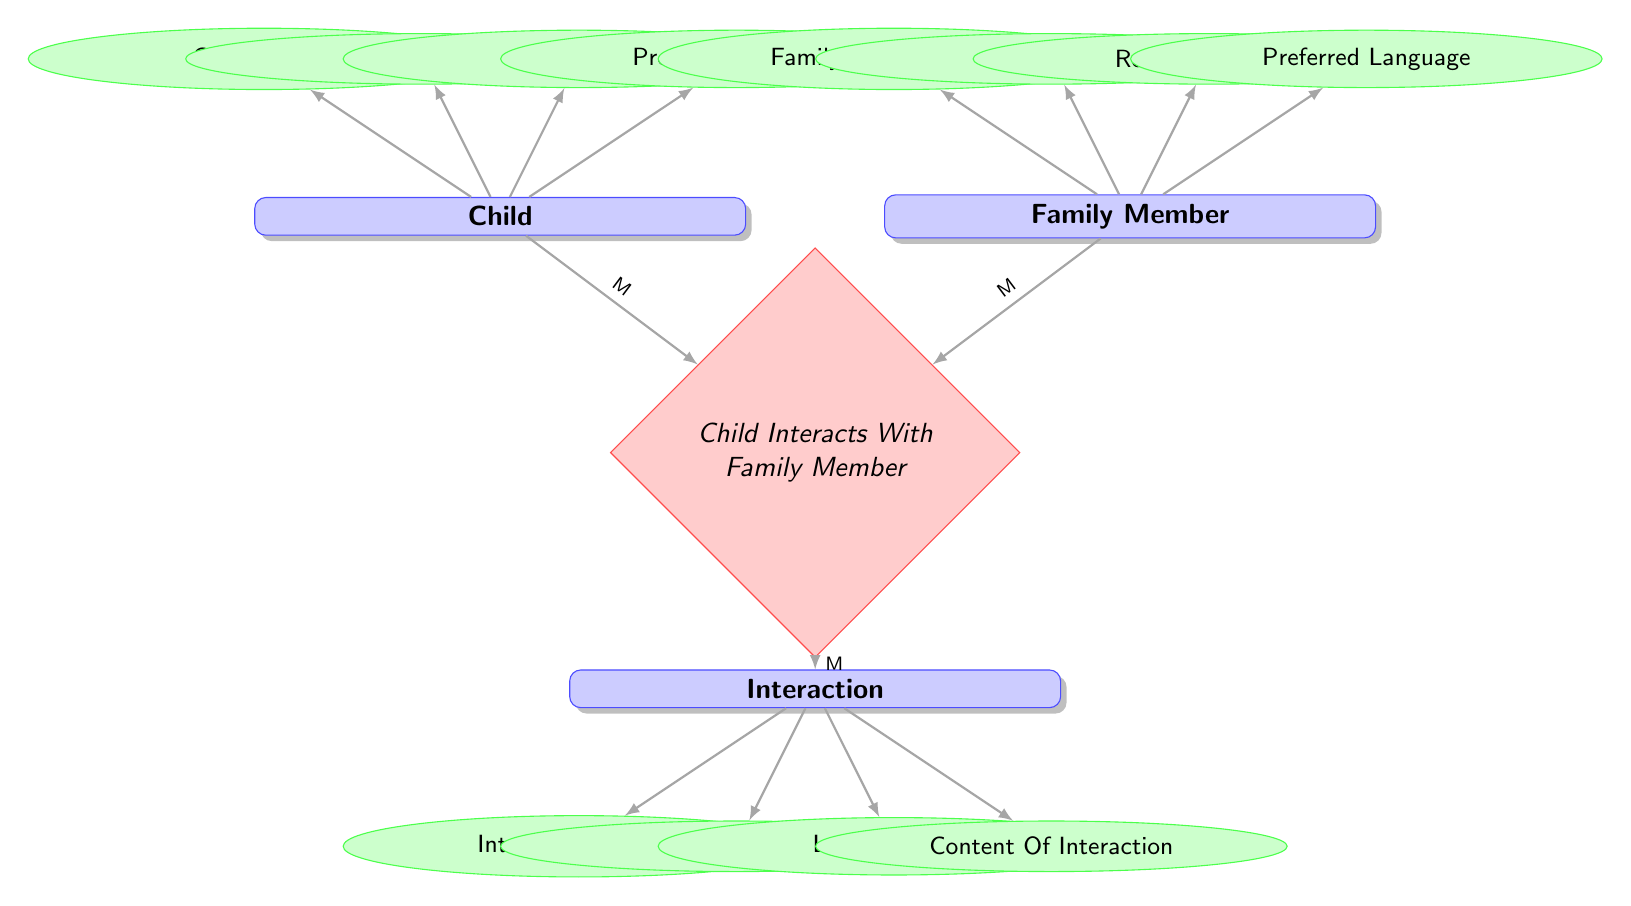What is the primary key for the Child entity? The primary key for the Child entity is "ChildID," as indicated in the attributes section connected to the Child entity.
Answer: ChildID How many relationships are present in the diagram? There are two relationships present in the diagram: "Child Interacts With Family Member" and "Interaction Details."
Answer: 2 What type of relationship exists between Child and Family Member? The relationship between Child and Family Member is a "Many-to-Many" relationship as specified under the "Child Interacts With Family Member" section.
Answer: Many-to-Many Which entity has the attribute "PreferredLanguage"? Both the Child entity and the Family Member entity have the attribute "PreferredLanguage" as described in their respective attribute sections.
Answer: Child, Family Member What is the relationship that connects Interaction with Child and Family Member? The relationship connecting Interaction with Child and Family Member is called "InteractionDetails," specifying that there is a One-to-Many relation from Child and FamilyMember to Interaction.
Answer: InteractionDetails How many attributes does the Family Member entity have? The Family Member entity has four attributes: FamilyMemberID, Name, RelationToChild, and PreferredLanguage, as shown in the entity’s attribute section.
Answer: 4 What does the "ContentOfInteraction" attribute describe? The "ContentOfInteraction" attribute describes the details of the interaction that occurred, as indicated in the Interaction entity's attributes.
Answer: Details of the interaction Which entity interacts with more than one Family Member? The Child entity interacts with more than one Family Member as it is mentioned in the relationship "Child Interacts With Family Member," which indicates a Many-to-Many relationship.
Answer: Child What is the cardinality of the relationship between Interaction and Child? The cardinality of the relationship between Interaction and Child is One-to-Many, as stated in the relationship "Interaction Details."
Answer: One-to-Many 